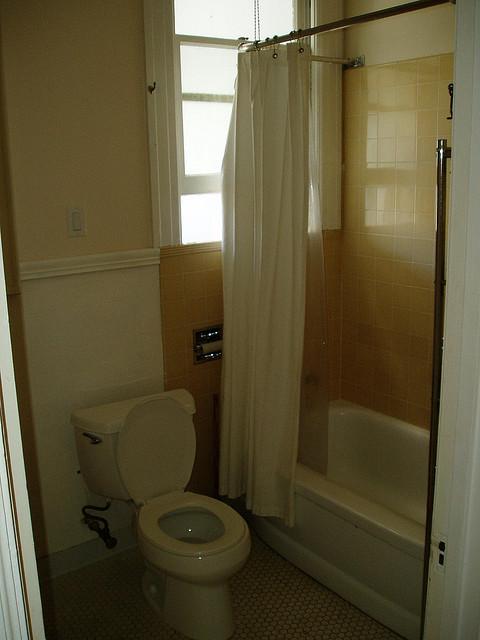Is this a men's bathroom?
Be succinct. No. Is there a mirror in this bathroom?
Answer briefly. No. Is there a tub in the picture?
Short answer required. Yes. Is the shower curtain long enough for the shower?
Concise answer only. Yes. Do you see a bathtub in this picture?
Concise answer only. Yes. Does the bathroom look ready for personal use?
Give a very brief answer. Yes. Is the toilet lid closed?
Give a very brief answer. No. What shape are the floor tiles?
Keep it brief. Square. Does the shower have glass doors?
Answer briefly. No. What is the motif on the shower curtain?
Give a very brief answer. Plain. What color are the walls?
Quick response, please. Beige. Is the toilet seat smooth?
Write a very short answer. Yes. Is the window open in the shower?
Answer briefly. Yes. Where is the shower curtain?
Short answer required. White. What is in the bathtub?
Keep it brief. Nothing. Is the toilet lid, up or down?
Concise answer only. Up. Is the window opened or closed?
Be succinct. Open. Is there a mirror?
Answer briefly. No. Is there a bathtub in this shower?
Answer briefly. Yes. Which city is this house in?
Keep it brief. New york city. What color is the shower tile?
Concise answer only. Yellow. Is the window open?
Concise answer only. Yes. What color is the toilet seat?
Concise answer only. White. Is the toilet lid down?
Write a very short answer. No. What color is the toilet?
Keep it brief. White. How big is the bathtub?
Keep it brief. Normal size. Is there a bathtub?
Give a very brief answer. Yes. Is the shower curtain hanging inside or outside of the bathtub?
Concise answer only. Outside. Why is a shower curtain needed?
Be succinct. Privacy. Is there toilet paper here?
Short answer required. No. 